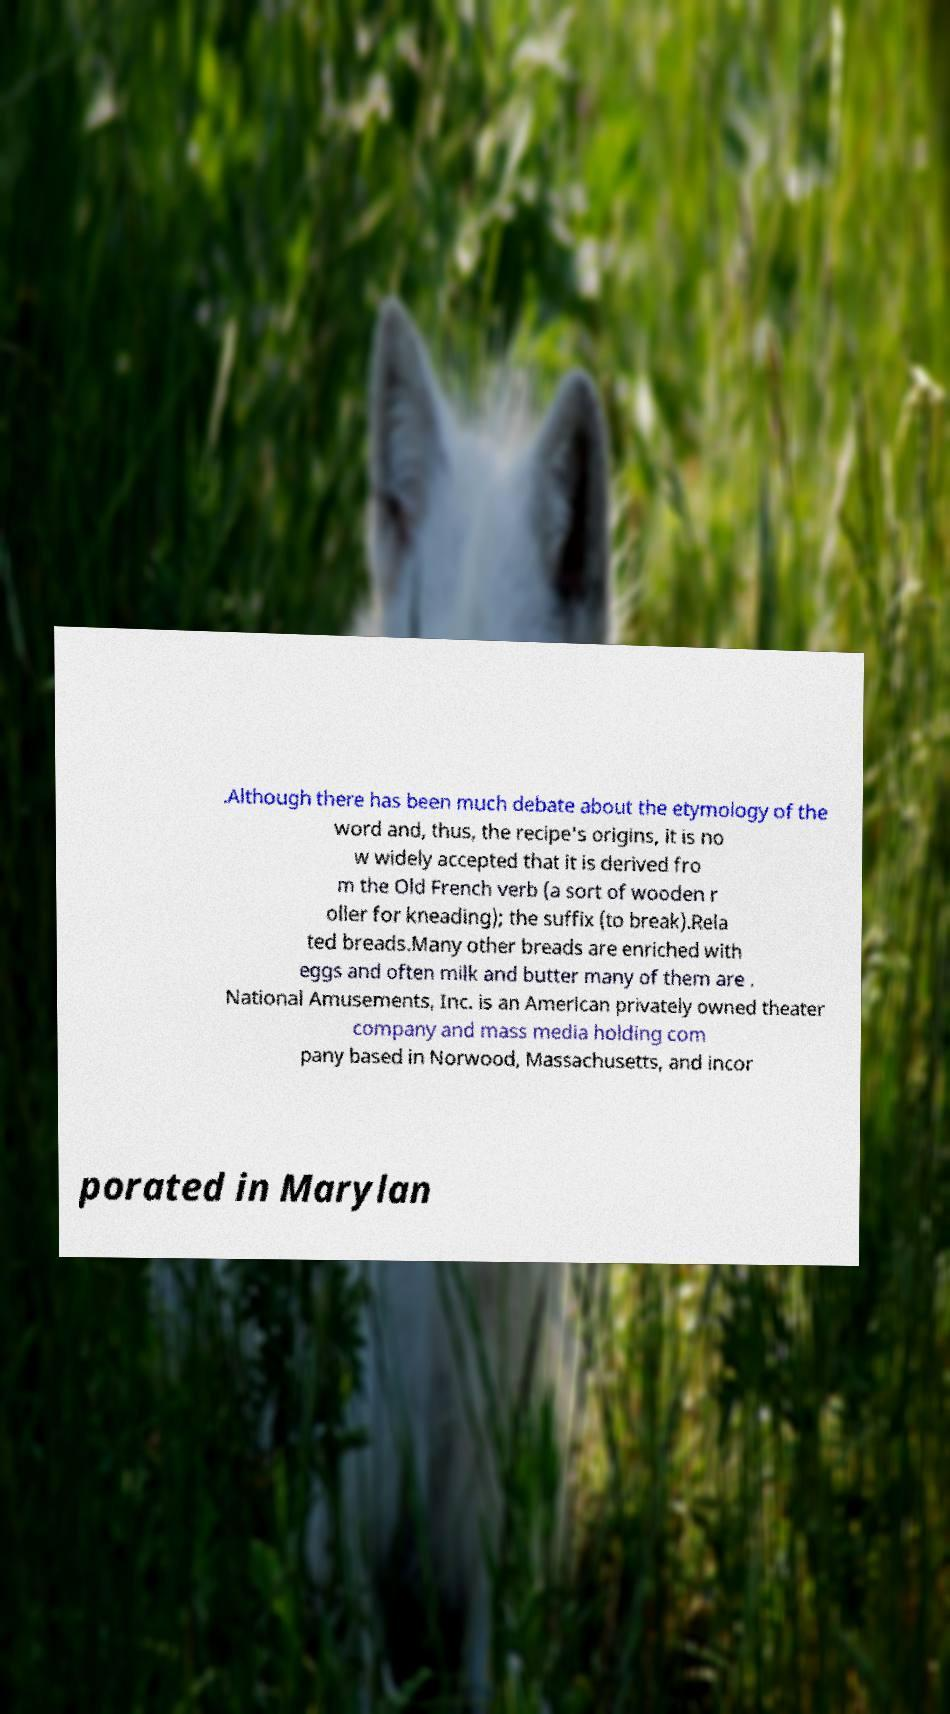There's text embedded in this image that I need extracted. Can you transcribe it verbatim? .Although there has been much debate about the etymology of the word and, thus, the recipe's origins, it is no w widely accepted that it is derived fro m the Old French verb (a sort of wooden r oller for kneading); the suffix (to break).Rela ted breads.Many other breads are enriched with eggs and often milk and butter many of them are . National Amusements, Inc. is an American privately owned theater company and mass media holding com pany based in Norwood, Massachusetts, and incor porated in Marylan 